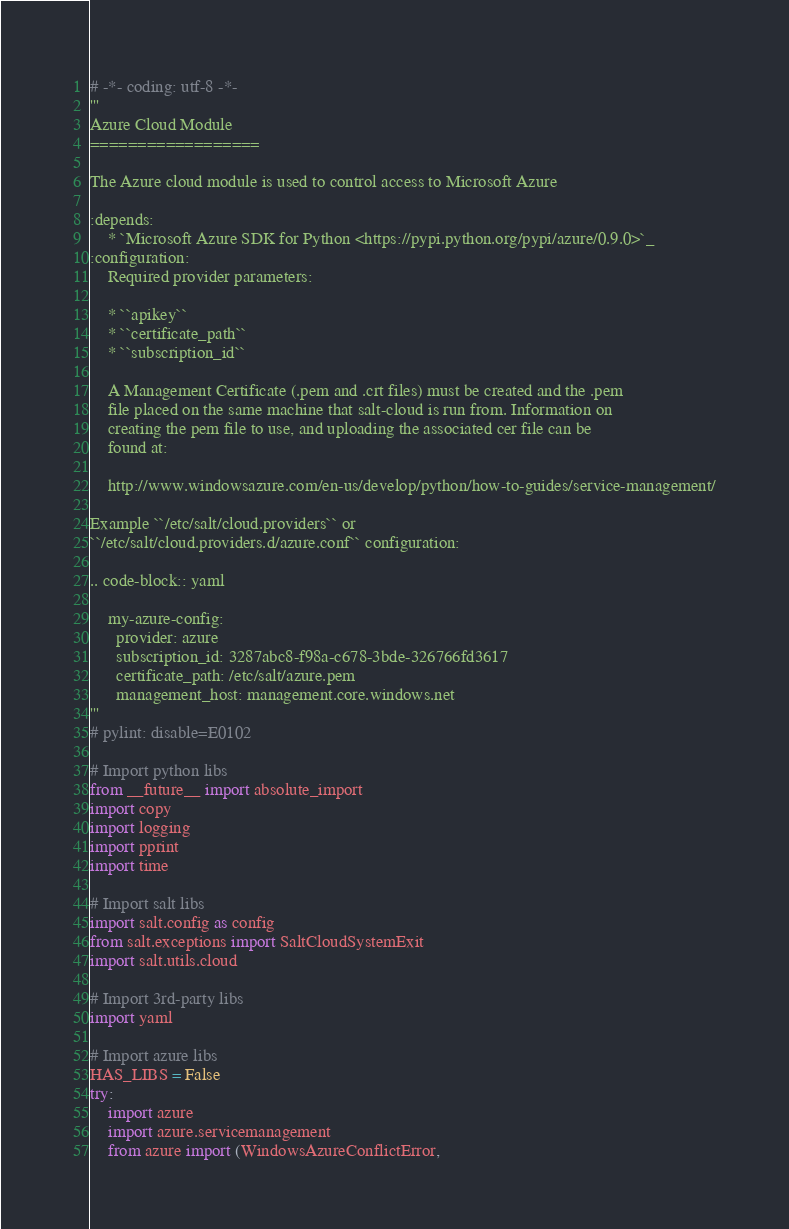<code> <loc_0><loc_0><loc_500><loc_500><_Python_># -*- coding: utf-8 -*-
'''
Azure Cloud Module
==================

The Azure cloud module is used to control access to Microsoft Azure

:depends:
    * `Microsoft Azure SDK for Python <https://pypi.python.org/pypi/azure/0.9.0>`_
:configuration:
    Required provider parameters:

    * ``apikey``
    * ``certificate_path``
    * ``subscription_id``

    A Management Certificate (.pem and .crt files) must be created and the .pem
    file placed on the same machine that salt-cloud is run from. Information on
    creating the pem file to use, and uploading the associated cer file can be
    found at:

    http://www.windowsazure.com/en-us/develop/python/how-to-guides/service-management/

Example ``/etc/salt/cloud.providers`` or
``/etc/salt/cloud.providers.d/azure.conf`` configuration:

.. code-block:: yaml

    my-azure-config:
      provider: azure
      subscription_id: 3287abc8-f98a-c678-3bde-326766fd3617
      certificate_path: /etc/salt/azure.pem
      management_host: management.core.windows.net
'''
# pylint: disable=E0102

# Import python libs
from __future__ import absolute_import
import copy
import logging
import pprint
import time

# Import salt libs
import salt.config as config
from salt.exceptions import SaltCloudSystemExit
import salt.utils.cloud

# Import 3rd-party libs
import yaml

# Import azure libs
HAS_LIBS = False
try:
    import azure
    import azure.servicemanagement
    from azure import (WindowsAzureConflictError,</code> 